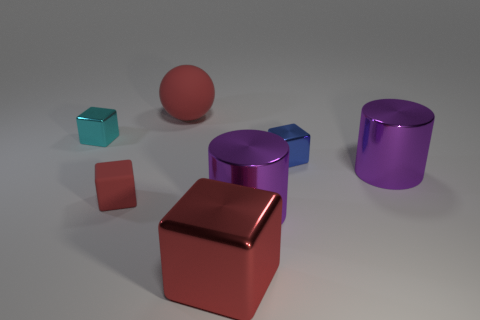Add 3 tiny brown metal cylinders. How many objects exist? 10 Subtract all small cyan metal blocks. How many blocks are left? 3 Subtract all cylinders. How many objects are left? 5 Subtract 4 blocks. How many blocks are left? 0 Subtract all blue balls. Subtract all brown cylinders. How many balls are left? 1 Subtract all brown spheres. How many green cylinders are left? 0 Subtract all small blue matte things. Subtract all metallic cylinders. How many objects are left? 5 Add 7 small blue blocks. How many small blue blocks are left? 8 Add 6 big matte things. How many big matte things exist? 7 Subtract all red blocks. How many blocks are left? 2 